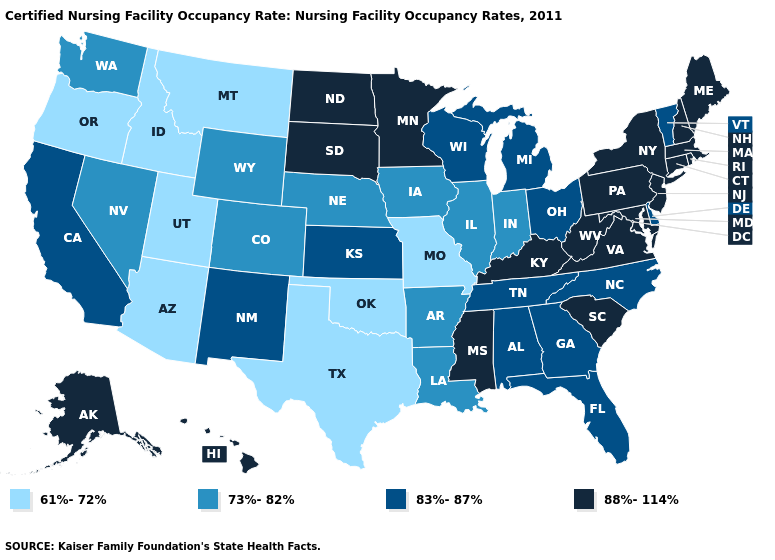What is the value of Indiana?
Keep it brief. 73%-82%. Which states have the lowest value in the Northeast?
Answer briefly. Vermont. What is the value of Delaware?
Give a very brief answer. 83%-87%. Does the first symbol in the legend represent the smallest category?
Concise answer only. Yes. Which states have the lowest value in the South?
Answer briefly. Oklahoma, Texas. Among the states that border Missouri , does Oklahoma have the highest value?
Keep it brief. No. Does the first symbol in the legend represent the smallest category?
Answer briefly. Yes. What is the value of Rhode Island?
Quick response, please. 88%-114%. Does Maryland have the highest value in the South?
Keep it brief. Yes. What is the value of Utah?
Write a very short answer. 61%-72%. Does Colorado have the same value as Arizona?
Short answer required. No. How many symbols are there in the legend?
Write a very short answer. 4. Does Florida have the lowest value in the South?
Keep it brief. No. Does Arizona have the lowest value in the West?
Quick response, please. Yes. Does Hawaii have the lowest value in the USA?
Answer briefly. No. 